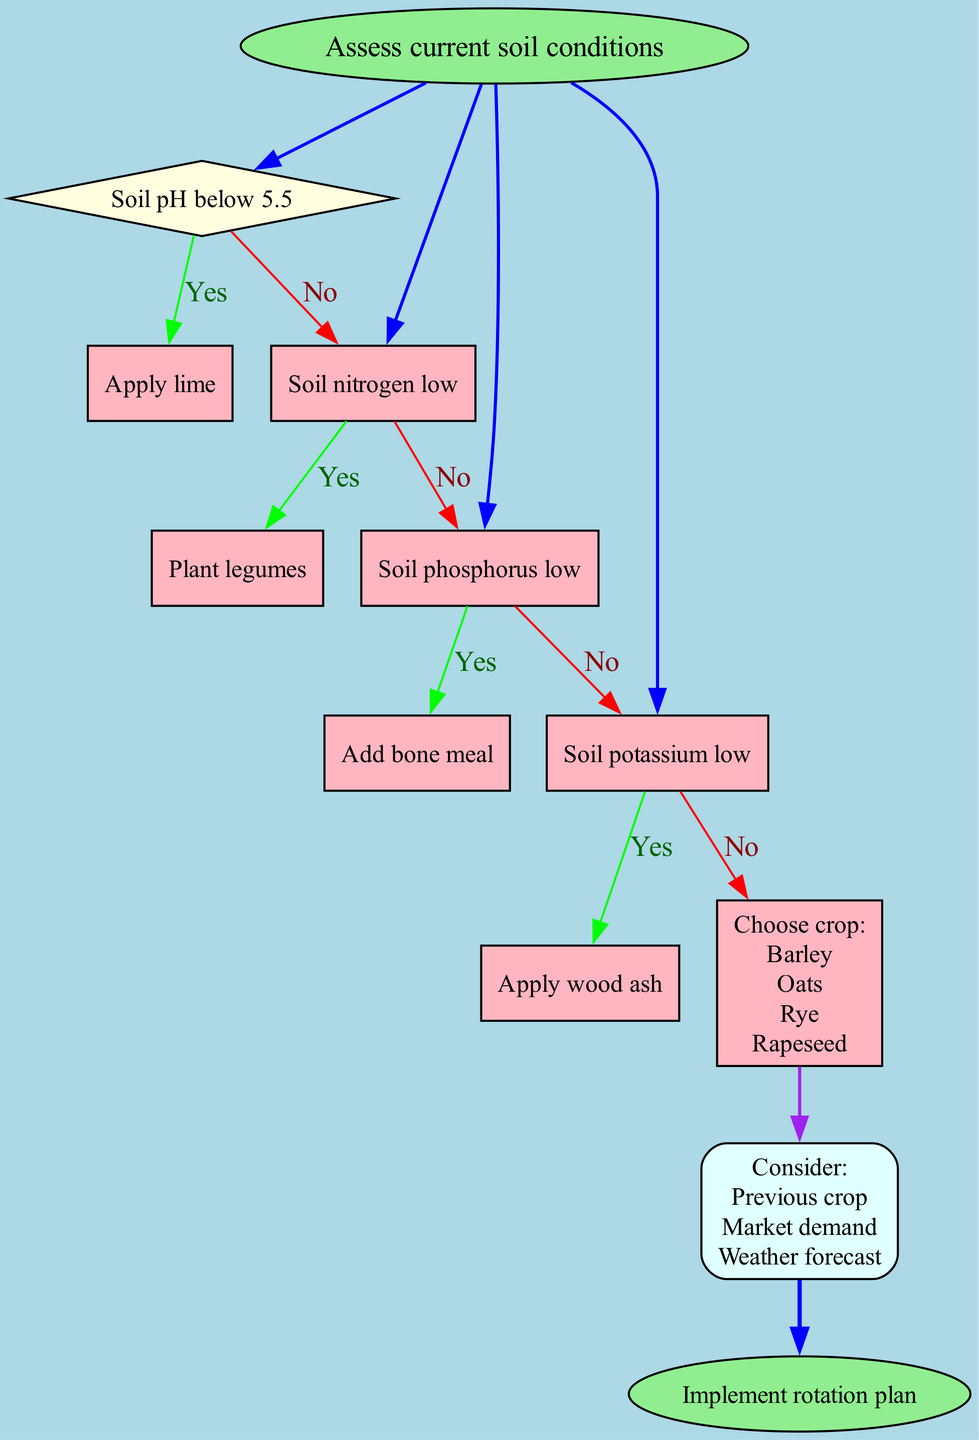What is the starting point of the flow chart? The starting point of the flow chart is labeled as "Assess current soil conditions." This is where the decision-making process begins.
Answer: Assess current soil conditions How many decision nodes are present in the diagram? The diagram has four decision nodes related to soil conditions, each representing a different criterion that affects decisions.
Answer: 4 What action is taken if the soil nitrogen is low? If the soil nitrogen is low, the action taken is to "Plant legumes." This node outlines the direct response to that specific condition.
Answer: Plant legumes Name one of the considerations when choosing a crop. One of the considerations mentioned in the diagram is "Previous crop." This consideration influences the crop selection process.
Answer: Previous crop What happens if the soil pH is not below 5.5? If the soil pH is not below 5.5, according to the flow chart, the decision-making proceeds to the next decision node (soil nitrogen). Hence, it leads to further assessments rather than applying lime.
Answer: Next decision node Which node represents the final step? The final step in the process is represented by the node labeled "Implement rotation plan," signifying the conclusion of the decision-making flow.
Answer: Implement rotation plan What color is used for the decision nodes? The decision nodes in the diagram are filled with a light yellow color to visually distinguish them from other types of nodes.
Answer: Light yellow If the soil phosphorus is low, what is the specified action? When the soil phosphorus is low, the specified action is to "Add bone meal," indicating a targeted treatment for that deficiency.
Answer: Add bone meal What do the nodes related to crop choices represent? The nodes related to crop choices represent the options available for selection, specifically "Barley," "Oats," "Rye," and "Rapeseed." They are all presented together to aid the decision.
Answer: Barley, Oats, Rye, Rapeseed 